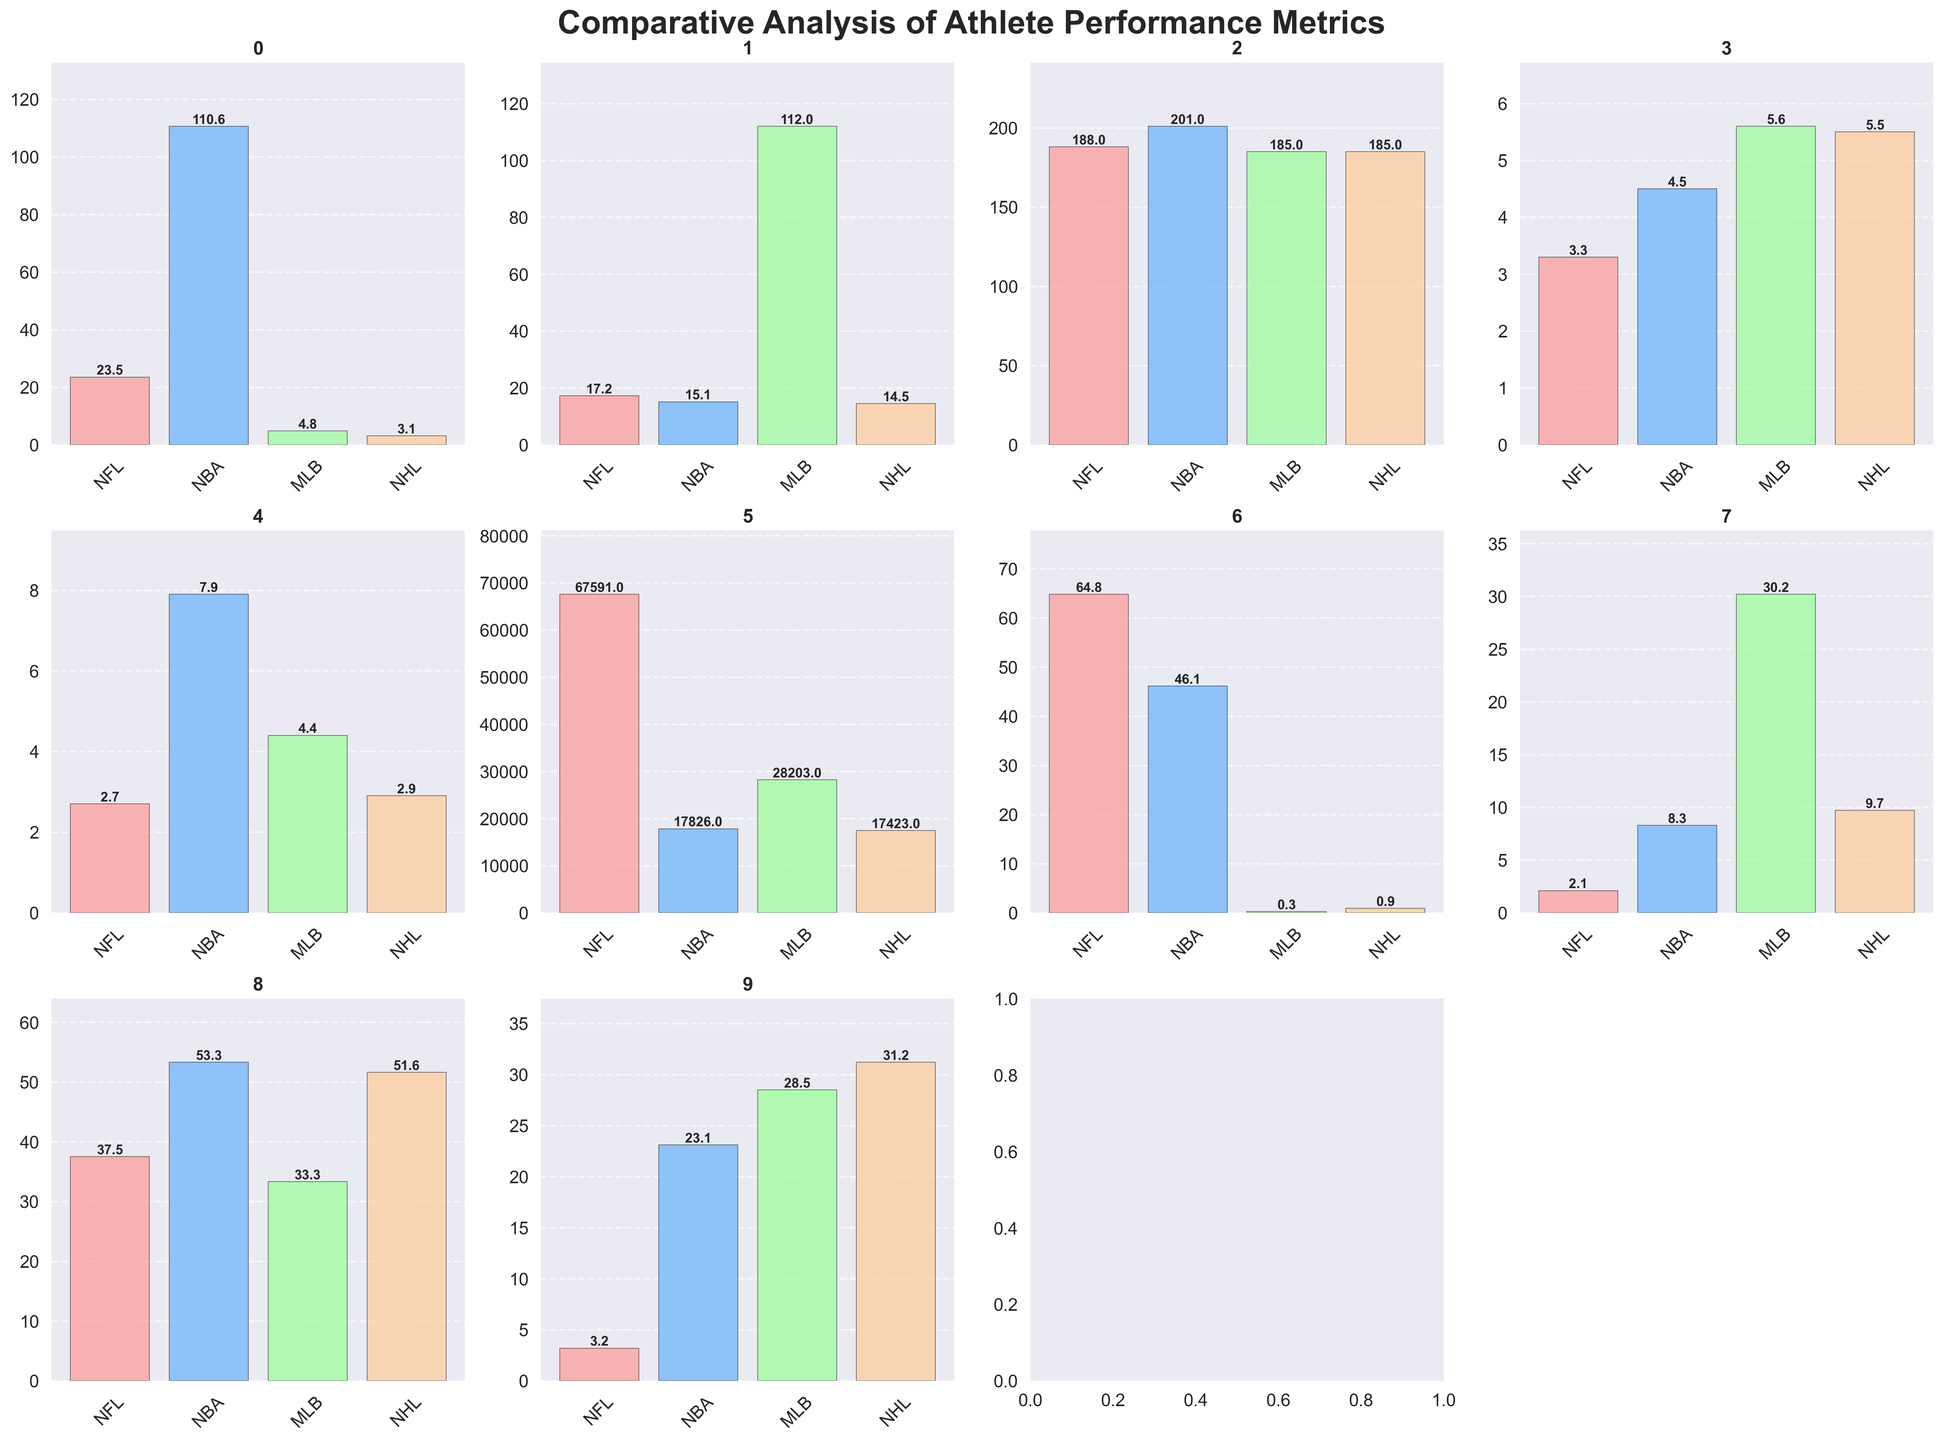what is the title of the figure? The title of the figure is located at the top and reads as 'Comparative Analysis of Athlete Performance Metrics'.
Answer: Comparative Analysis of Athlete Performance Metrics Which sport league has the highest average annual salary? The average annual salaries are shown in one of the subplots with bars representing each league's salary. The NBA has the highest bar.
Answer: NBA How does the average height of athletes in the NBA compare to those in the NFL and MLB? The subplot for average height shows that NBA athletes have the highest average height compared to NFL and MLB based on the bar heights.
Answer: NBA athletes are taller What is the difference in average points scored per game between NFL and NBA? The scoring metric subplot shows that the NFL has an average of 23.5 points per game, while the NBA has 110.6 points per game. The difference is 110.6 - 23.5 = 87.1.
Answer: 87.1 Which league has the lowest player efficiency metric, and what is the value? The subplot for player efficiency metrics shows that the NBA bar is the lowest with a value of 15.1.
Answer: NBA, 15.1 What is the ratio of average attendance between NFL and NBA? From the fan engagement subplot, NFL's average attendance is 67591 and NBA's is 17826. The ratio is 67591 ÷ 17826 ≈ 3.79.
Answer: 3.79 What is the average career length of athletes in MLB and NHL and how does it compare? The average career lengths for MLB and NHL are both represented in a subplot. MLB has 5.6 years, and NHL has 5.5 years.
Answer: MLB is slightly longer, 5.6 years vs. 5.5 years How many sports leagues have games missed per season above 8? The injuries subplot shows that both NBA (8.3) and NHL (9.7) have games missed per season above 8.
Answer: Two leagues Compare the percentage of international players in the MLB and NHL. The global reach subplot shows that MLB has 28.5% and NHL has 31.2%. NHL has a higher percentage.
Answer: NHL, 31.2% What is the average performance metric across all leagues? Adding the performance metrics from each subplot gives 64.8 (NFL) + 46.1 (NBA) + 0.252 (MLB) + 0.910 (NHL) = 112.062. Divide by 4 for the average: 112.062 ÷ 4 = 28.0155.
Answer: 28.0155 